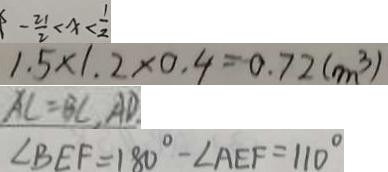Convert formula to latex. <formula><loc_0><loc_0><loc_500><loc_500>- \frac { 2 1 } { 2 } < x < \frac { 1 } { 2 } 
 1 . 5 \times 1 . 2 \times 0 . 4 = 0 . 7 2 ( m ^ { 3 } ) 
 A C = B C , A D 
 \angle B E F = 1 8 0 ^ { \circ } - \angle A E F = 1 1 0 ^ { \circ }</formula> 